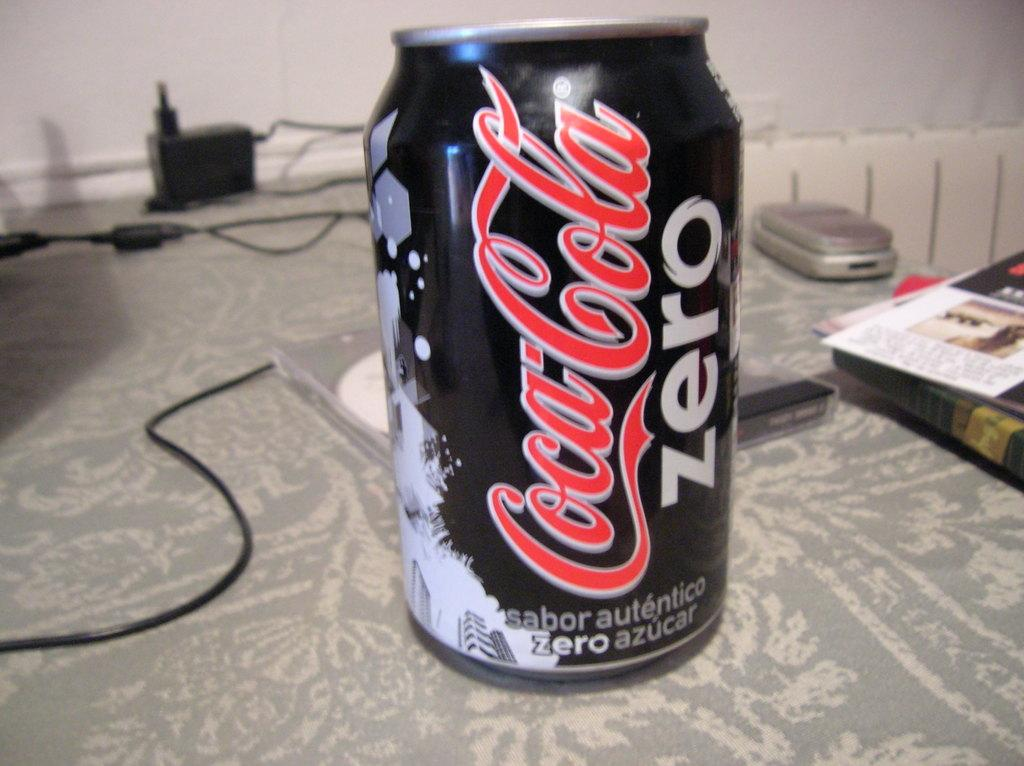<image>
Offer a succinct explanation of the picture presented. A black and red can of Coca Cola Zero on a table. 